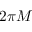<formula> <loc_0><loc_0><loc_500><loc_500>2 \pi M</formula> 